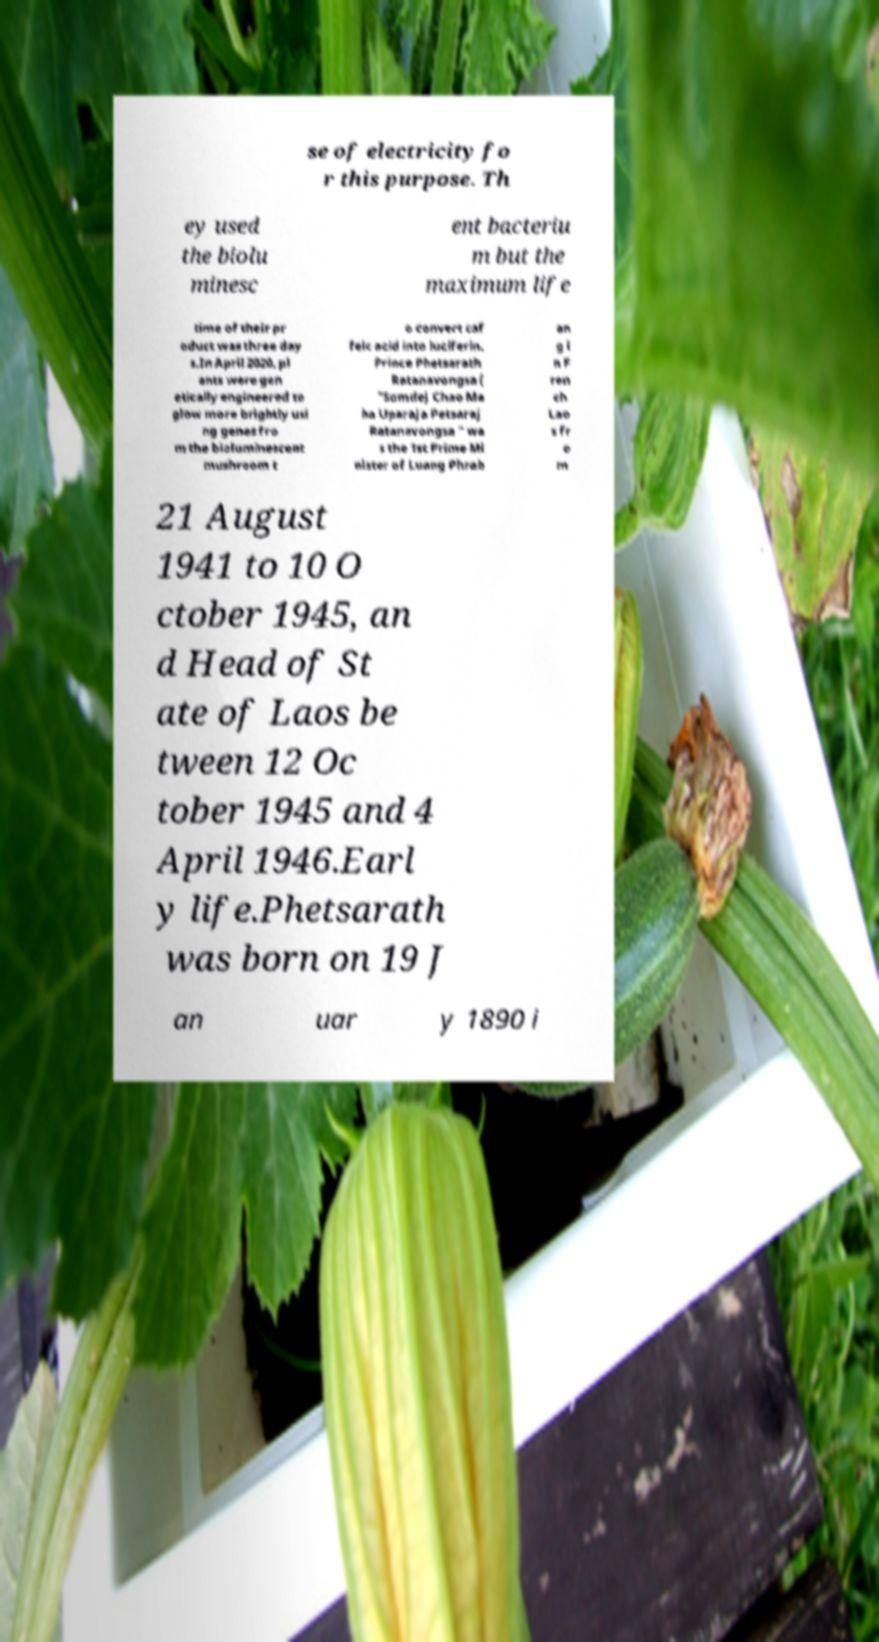What messages or text are displayed in this image? I need them in a readable, typed format. se of electricity fo r this purpose. Th ey used the biolu minesc ent bacteriu m but the maximum life time of their pr oduct was three day s.In April 2020, pl ants were gen etically engineered to glow more brightly usi ng genes fro m the bioluminescent mushroom t o convert caf feic acid into luciferin. Prince Phetsarath Ratanavongsa ( "Somdej Chao Ma ha Uparaja Petsaraj Ratanavongsa " wa s the 1st Prime Mi nister of Luang Phrab an g i n F ren ch Lao s fr o m 21 August 1941 to 10 O ctober 1945, an d Head of St ate of Laos be tween 12 Oc tober 1945 and 4 April 1946.Earl y life.Phetsarath was born on 19 J an uar y 1890 i 